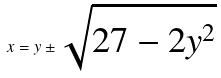<formula> <loc_0><loc_0><loc_500><loc_500>x = y \pm \sqrt { 2 7 - 2 y ^ { 2 } }</formula> 